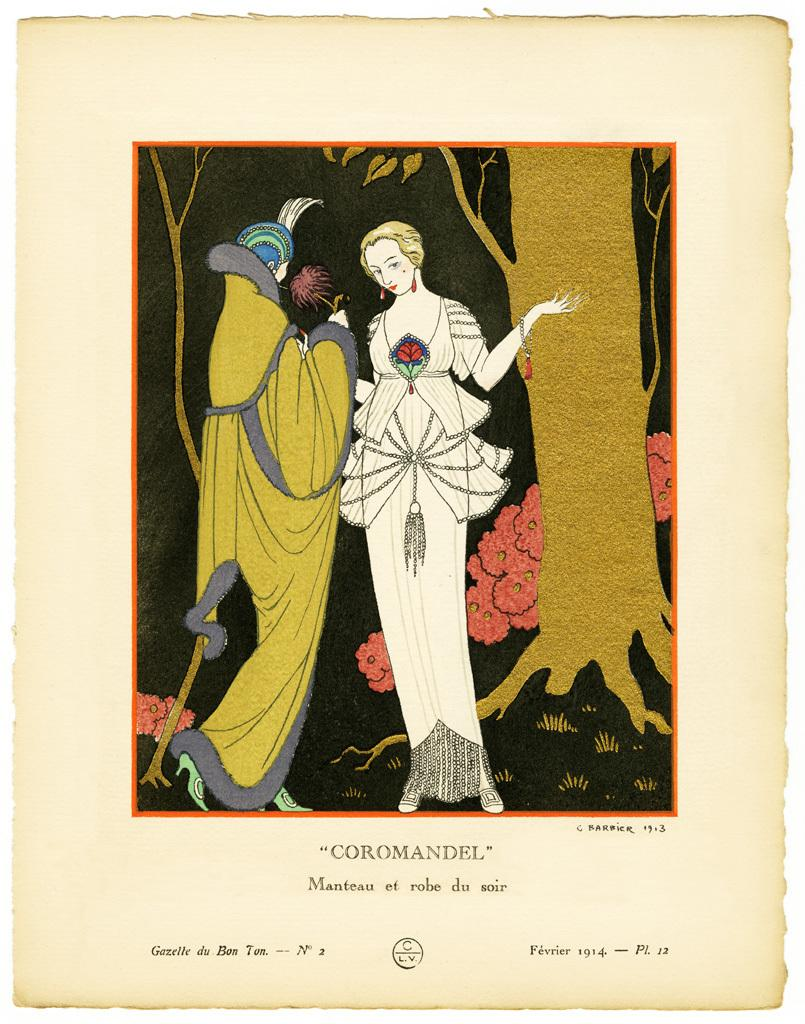What can be found in the image? There is a magazine in the image. What is depicted on the magazine cover? The magazine has a painting of a woman. Are there any other figures in the painting? Yes, there is a person standing beside the woman in the painting. What is written under the painting? The name "Coromandel" is written under the painting. What type of yarn is being used by the person in the painting? There is no yarn present in the image; the painting only depicts a woman and a person standing beside her. 